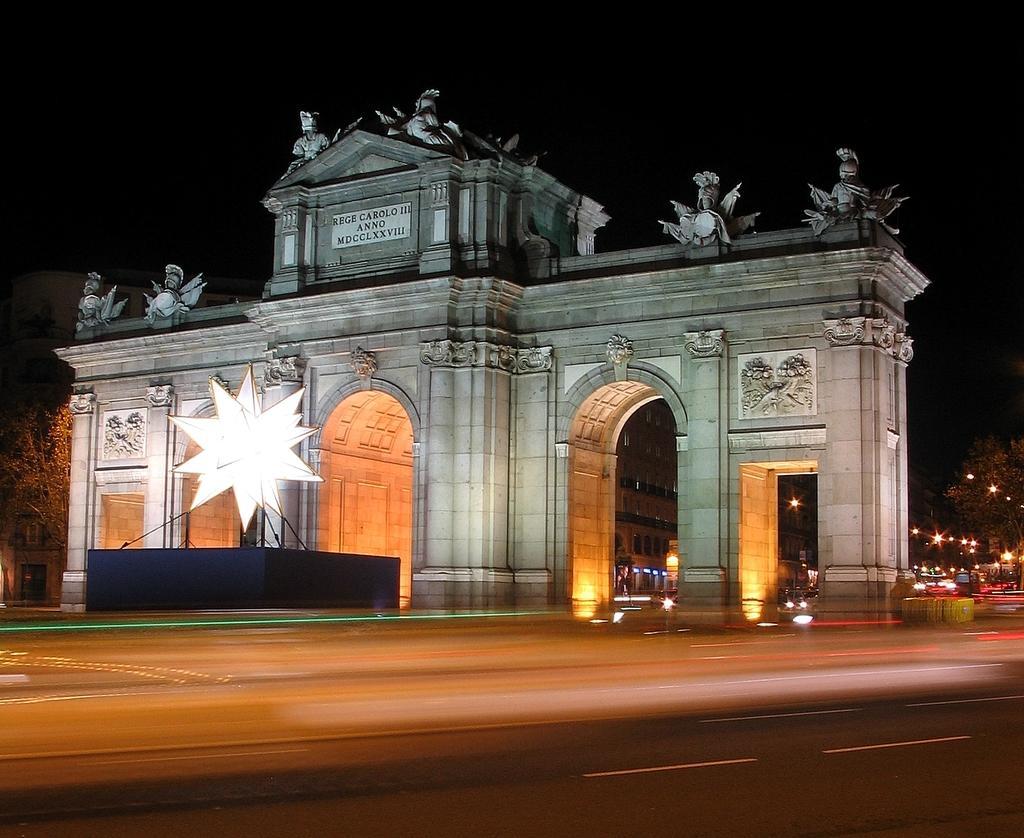Could you give a brief overview of what you see in this image? In this image I can see a road in the front. In the background I can see few buildings, number of lights and on the both sides of the image I can see few trees. On the top of the one building I can see number of sculptures and on the top side of the building I can say something is written. I can also see a white thing in the front of the building. 